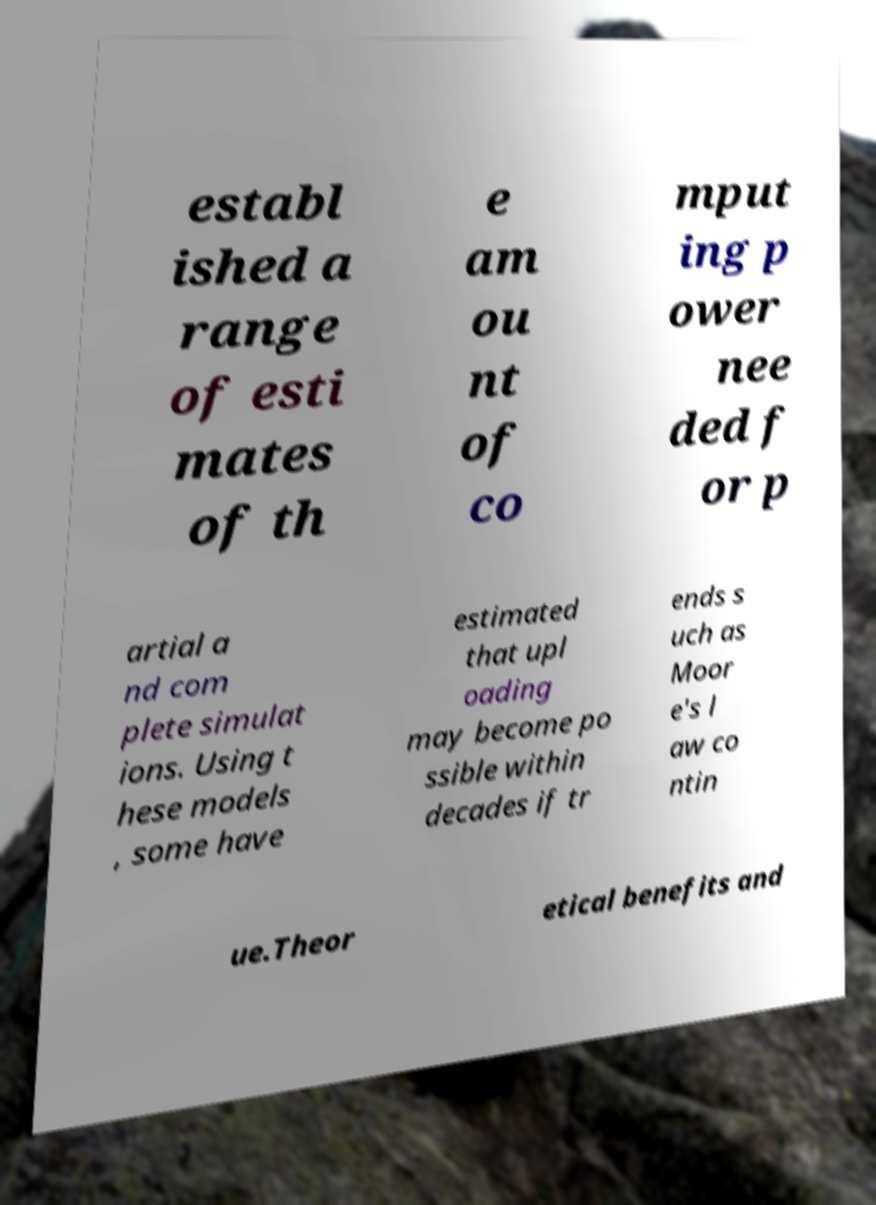There's text embedded in this image that I need extracted. Can you transcribe it verbatim? establ ished a range of esti mates of th e am ou nt of co mput ing p ower nee ded f or p artial a nd com plete simulat ions. Using t hese models , some have estimated that upl oading may become po ssible within decades if tr ends s uch as Moor e's l aw co ntin ue.Theor etical benefits and 